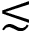Convert formula to latex. <formula><loc_0><loc_0><loc_500><loc_500>\lesssim</formula> 